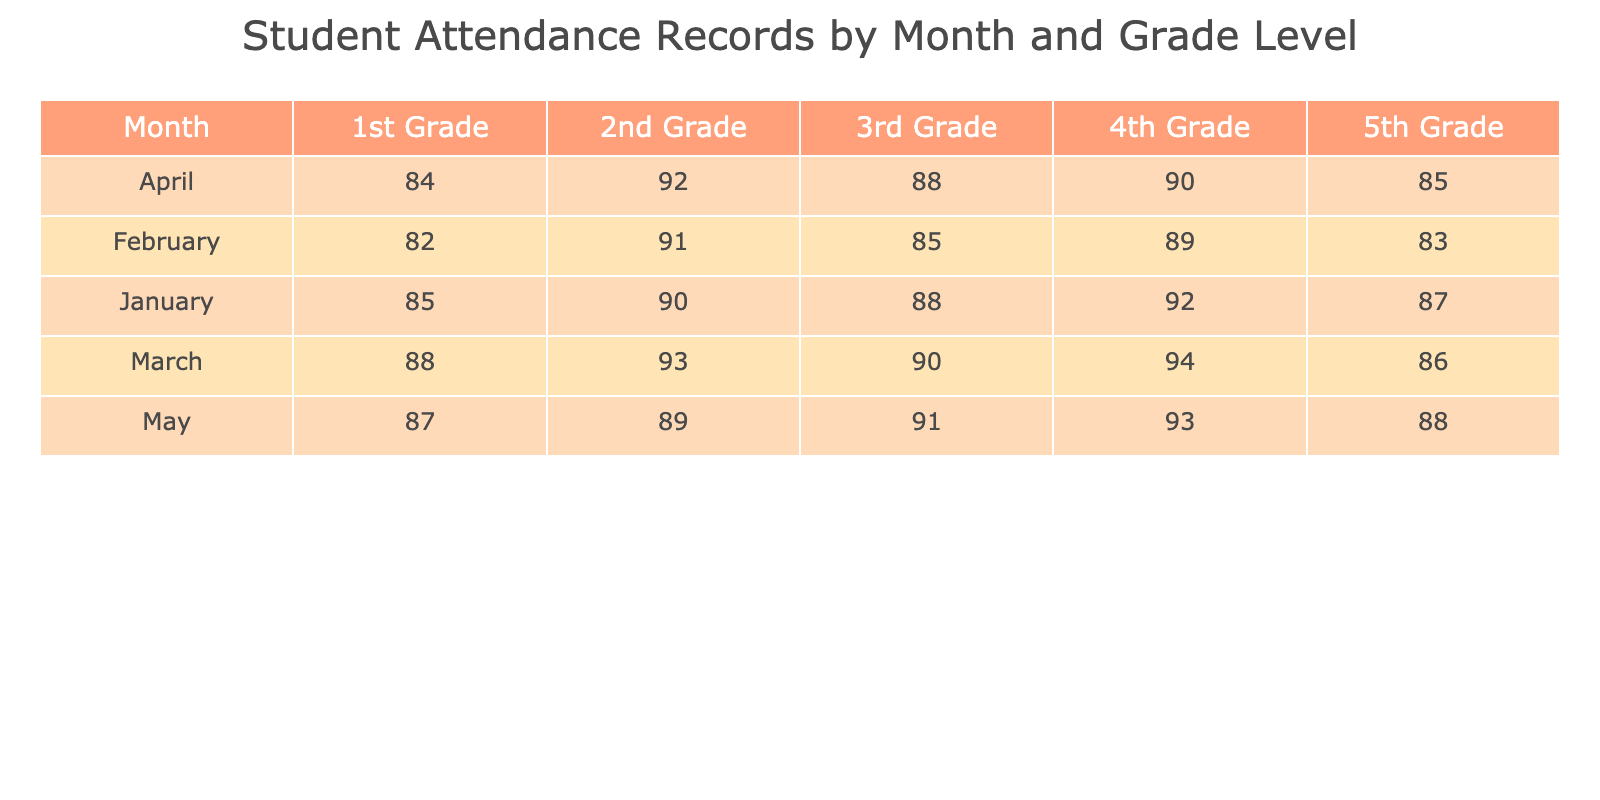What is the student attendance for 3rd Grade in February? Referring to the table, under February, the attendance value for 3rd Grade is specifically listed as 85.
Answer: 85 Which month had the highest student attendance in 1st Grade? Looking through the 1st Grade row across the months, January has 85, February has 82, March has 88, April has 84, and May has 87. The highest value among these is March with an attendance of 88.
Answer: March What is the average student attendance for 5th Grade over the five months? The student attendance for 5th Grade is: January 87, February 83, March 86, April 85, and May 88. Calculating the average: (87 + 83 + 86 + 85 + 88) = 429, and the number of months is 5, so the average is 429/5 = 85.8.
Answer: 85.8 Did 2nd Grade have more than 90% attendance in any month? Checking the attendance percentages for 2nd Grade: January 90, February 91, March 93, April 92, and May 89. Since there are months (February, March, and April) where attendance is above 90, the answer is yes.
Answer: Yes What is the difference in student attendance between 4th Grade in March and in January? In March, the attendance for 4th Grade is 94, while in January it is 92. To find the difference, we subtract January’s number from March's: 94 - 92 = 2.
Answer: 2 In which month does 3rd Grade show its lowest attendance? Looking at the 3rd Grade attendance across all months: January 88, February 85, March 90, April 88, May 91. The lowest value is in February with an attendance of 85.
Answer: February What was the total student attendance for all grades in April? Adding the attendance figures for all grades in April: 1st Grade 84, 2nd Grade 92, 3rd Grade 88, 4th Grade 90, and 5th Grade 85, gives us a total of 84 + 92 + 88 + 90 + 85 = 439.
Answer: 439 Is the student attendance in May for 5th Grade higher than 90? In May, the attendance for 5th Grade is listed as 88, which is below 90. Therefore, the statement is false.
Answer: No 